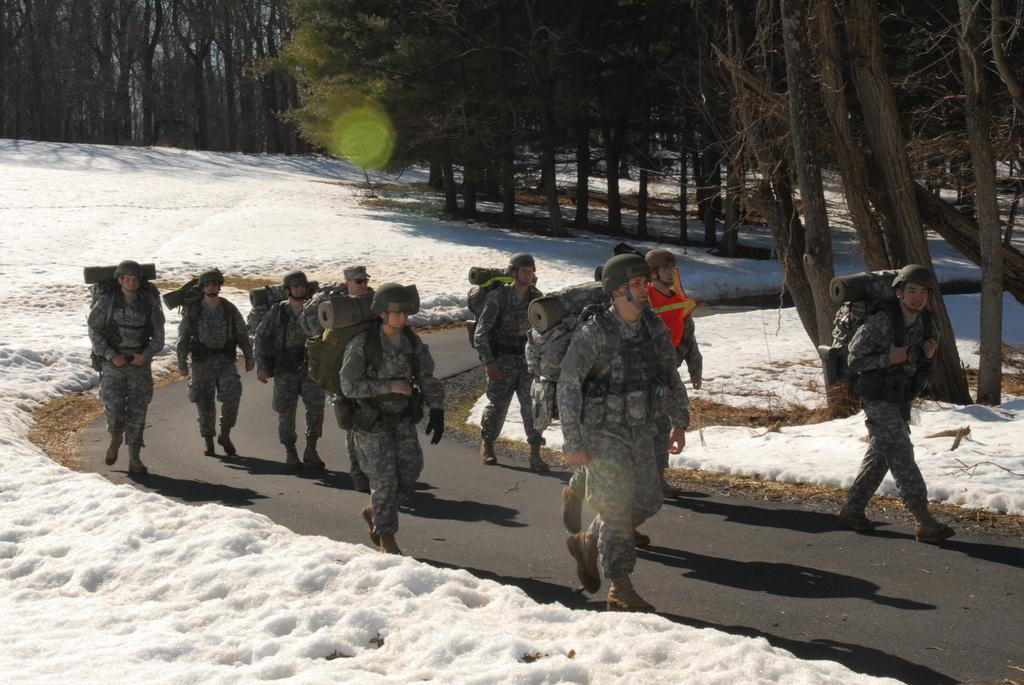What is happening on the road in the image? There are people on the road in the image. What are the people holding? The people are holding bags. What is the condition of the ground in the image? There is snow on the ground in the image. What type of vegetation can be seen in the image? There are trees visible in the image. How many snakes are slithering on the snow in the image? There are no snakes present in the image; it features people holding bags on a snowy road. Can you describe the kiss between the two people in the image? There are no people kissing in the image; the people are holding bags and walking on the snowy road. 